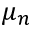<formula> <loc_0><loc_0><loc_500><loc_500>\mu _ { n }</formula> 